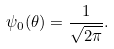Convert formula to latex. <formula><loc_0><loc_0><loc_500><loc_500>\psi _ { 0 } ( \theta ) = \frac { 1 } { \sqrt { 2 \pi } } .</formula> 